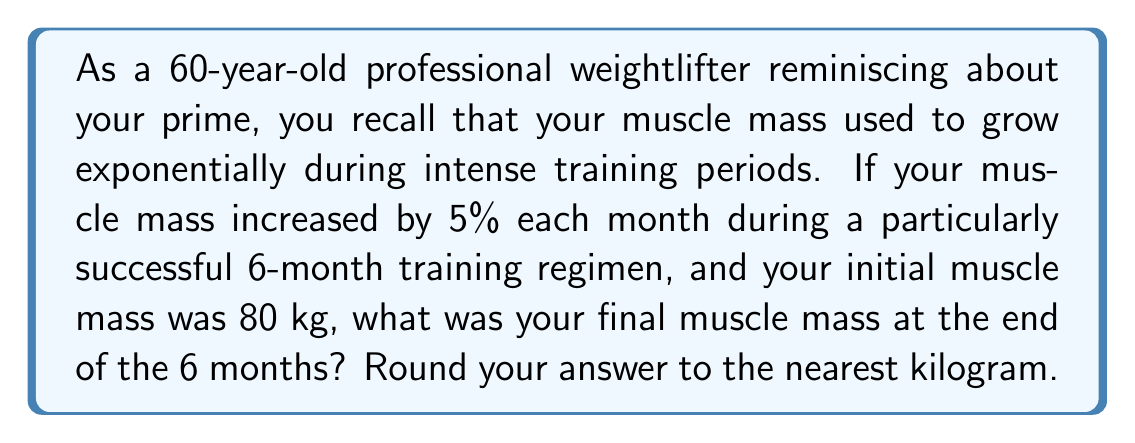Provide a solution to this math problem. Let's approach this step-by-step:

1) We're dealing with exponential growth, which can be modeled by the equation:

   $A = P(1 + r)^t$

   Where:
   $A$ = final amount
   $P$ = initial amount (principal)
   $r$ = growth rate (as a decimal)
   $t$ = time periods

2) In this case:
   $P = 80$ kg (initial muscle mass)
   $r = 0.05$ (5% growth rate per month)
   $t = 6$ months

3) Let's plug these values into our equation:

   $A = 80(1 + 0.05)^6$

4) Simplify inside the parentheses:

   $A = 80(1.05)^6$

5) Now, let's calculate $(1.05)^6$:

   $(1.05)^6 = 1.3401...$ 

6) Multiply this by our initial mass:

   $A = 80 \times 1.3401... = 107.2080...$

7) Rounding to the nearest kilogram:

   $A \approx 107$ kg
Answer: 107 kg 